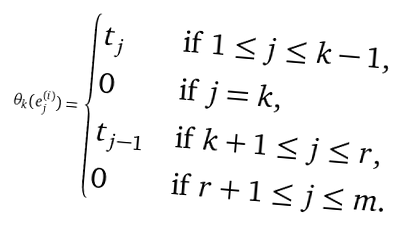<formula> <loc_0><loc_0><loc_500><loc_500>\theta _ { k } ( e _ { j } ^ { ( i ) } ) = \begin{cases} t _ { j } & \text {if $1 \leq j \leq k-1$,} \\ 0 & \text {if $j = k$,} \\ t _ { j - 1 } & \text {if $k+1 \leq j \leq r$,} \\ 0 & \text {if $r+1 \leq j \leq m$.} \end{cases}</formula> 